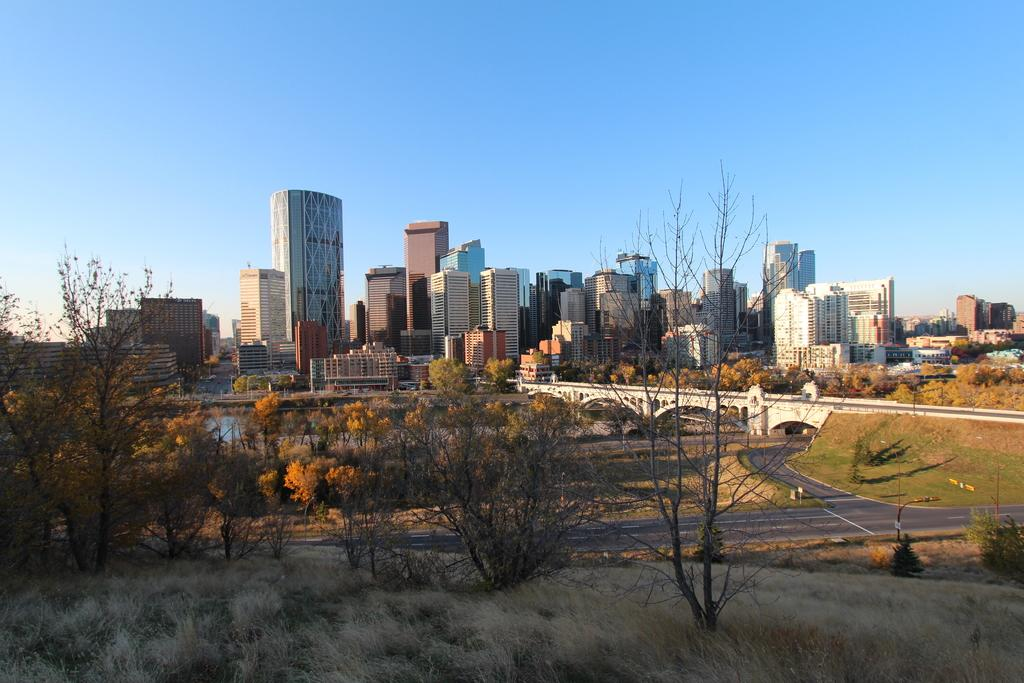What types of structures are present in the image? There are buildings and houses in the image. What natural elements can be seen in the image? There are trees and plants in the image. What type of man-made structure connects two areas in the image? There is a connecting bridge in the image. Can you describe any other elements in the image? There are other unspecified things around in the image. What type of advertisement can be seen on the side of the building in the image? There is no advertisement visible on the side of any building in the image. How many babies are present in the image? There are no babies present in the image. 